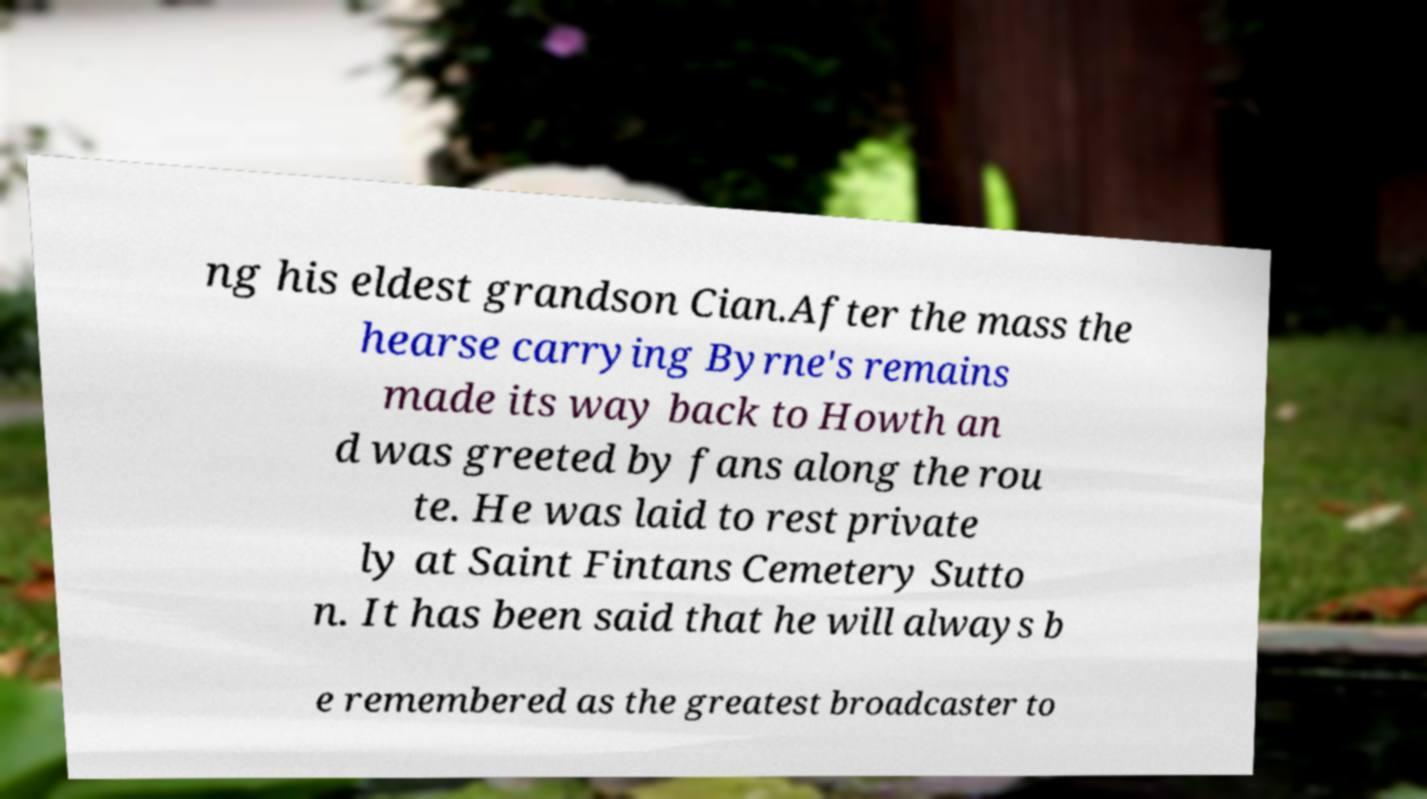Can you read and provide the text displayed in the image?This photo seems to have some interesting text. Can you extract and type it out for me? ng his eldest grandson Cian.After the mass the hearse carrying Byrne's remains made its way back to Howth an d was greeted by fans along the rou te. He was laid to rest private ly at Saint Fintans Cemetery Sutto n. It has been said that he will always b e remembered as the greatest broadcaster to 